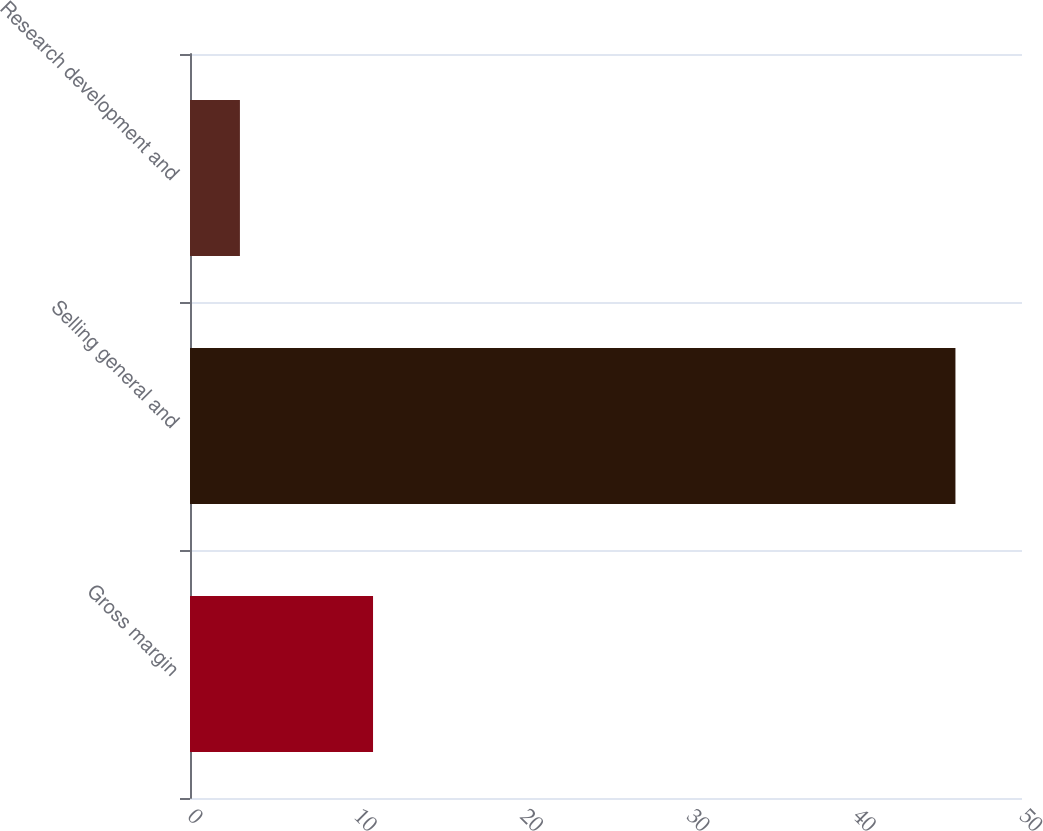Convert chart to OTSL. <chart><loc_0><loc_0><loc_500><loc_500><bar_chart><fcel>Gross margin<fcel>Selling general and<fcel>Research development and<nl><fcel>11<fcel>46<fcel>3<nl></chart> 